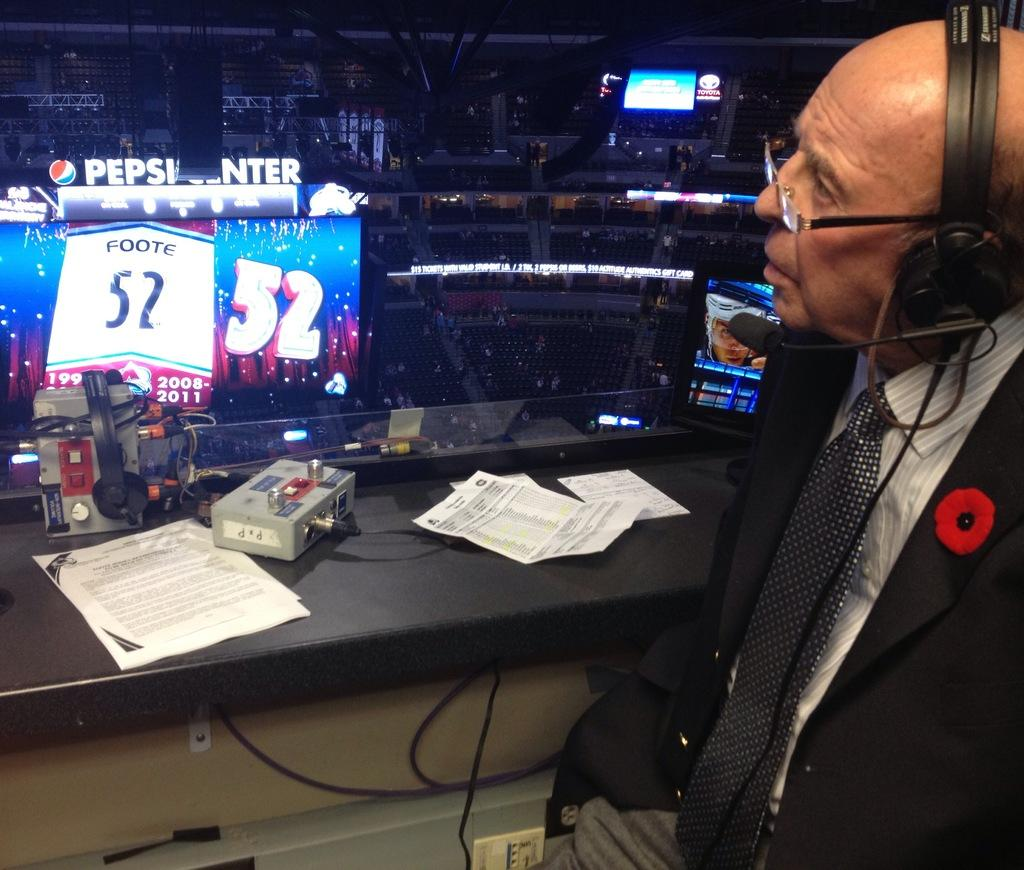<image>
Provide a brief description of the given image. A commentator at the Pepsi Center sits at a desk. 